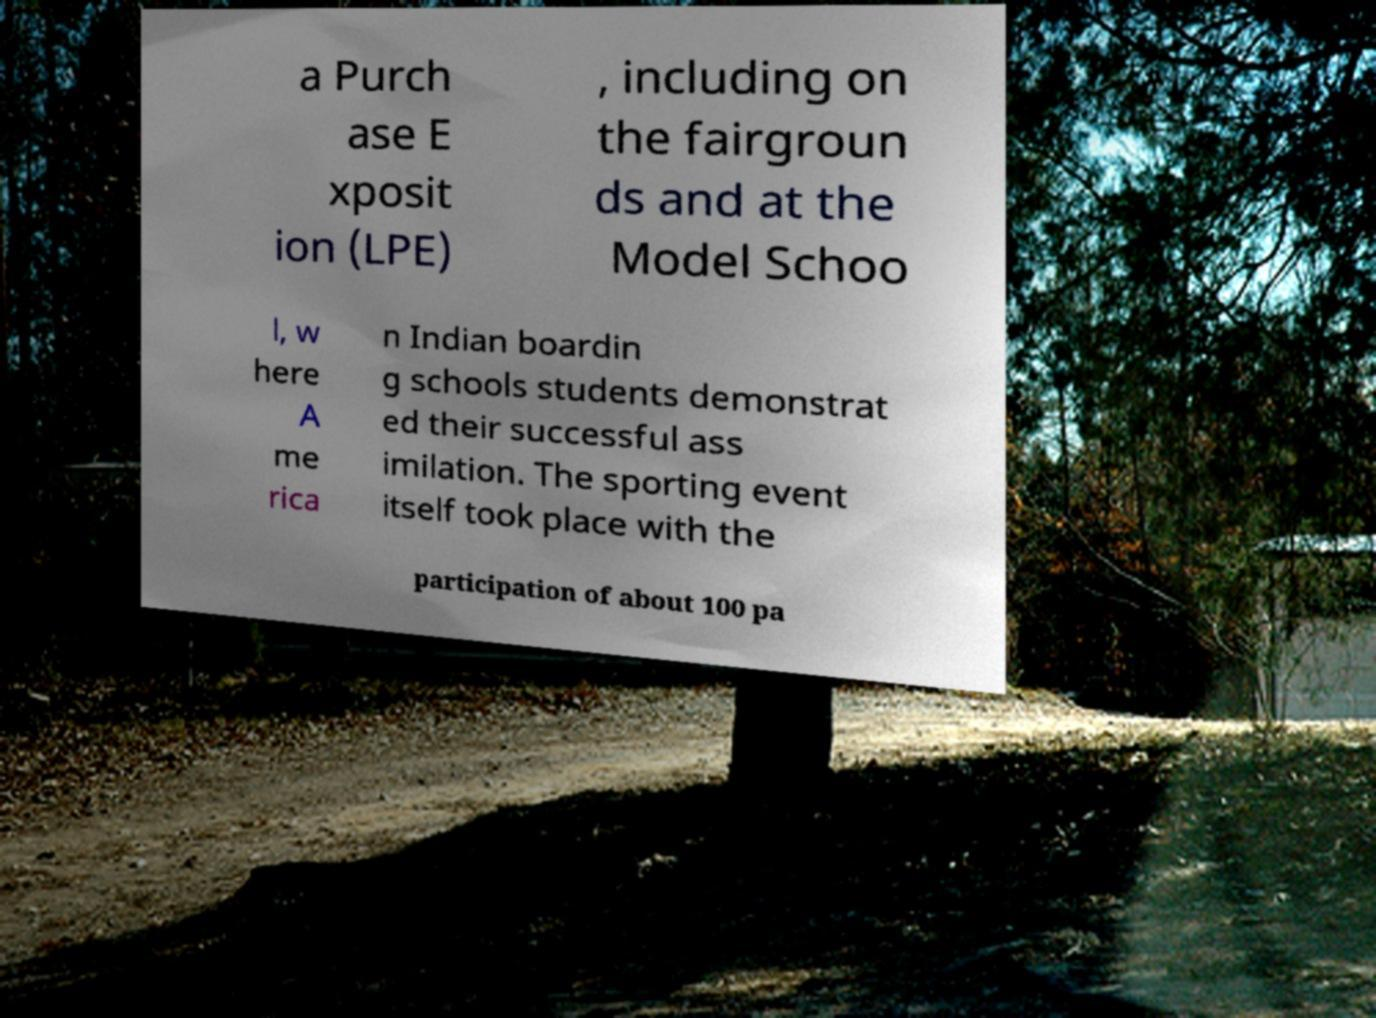I need the written content from this picture converted into text. Can you do that? a Purch ase E xposit ion (LPE) , including on the fairgroun ds and at the Model Schoo l, w here A me rica n Indian boardin g schools students demonstrat ed their successful ass imilation. The sporting event itself took place with the participation of about 100 pa 